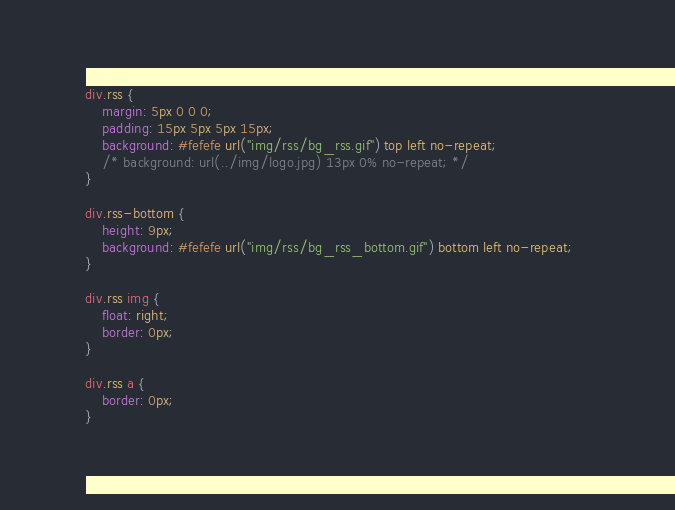<code> <loc_0><loc_0><loc_500><loc_500><_CSS_>div.rss {
	margin: 5px 0 0 0;
	padding: 15px 5px 5px 15px;
	background: #fefefe url("img/rss/bg_rss.gif") top left no-repeat;
	/* background: url(../img/logo.jpg) 13px 0% no-repeat; */
}

div.rss-bottom {
	height: 9px;
	background: #fefefe url("img/rss/bg_rss_bottom.gif") bottom left no-repeat;	
}

div.rss img {
	float: right;
	border: 0px;
}

div.rss a {
	border: 0px;
}</code> 